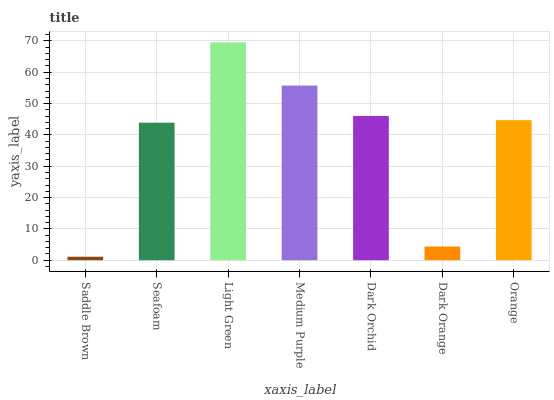Is Seafoam the minimum?
Answer yes or no. No. Is Seafoam the maximum?
Answer yes or no. No. Is Seafoam greater than Saddle Brown?
Answer yes or no. Yes. Is Saddle Brown less than Seafoam?
Answer yes or no. Yes. Is Saddle Brown greater than Seafoam?
Answer yes or no. No. Is Seafoam less than Saddle Brown?
Answer yes or no. No. Is Orange the high median?
Answer yes or no. Yes. Is Orange the low median?
Answer yes or no. Yes. Is Medium Purple the high median?
Answer yes or no. No. Is Dark Orange the low median?
Answer yes or no. No. 